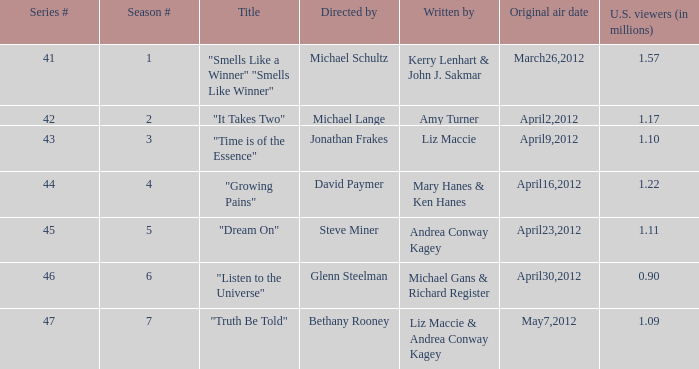What are the titles of the episodes which had 1.10 million U.S. viewers? "Time is of the Essence". 